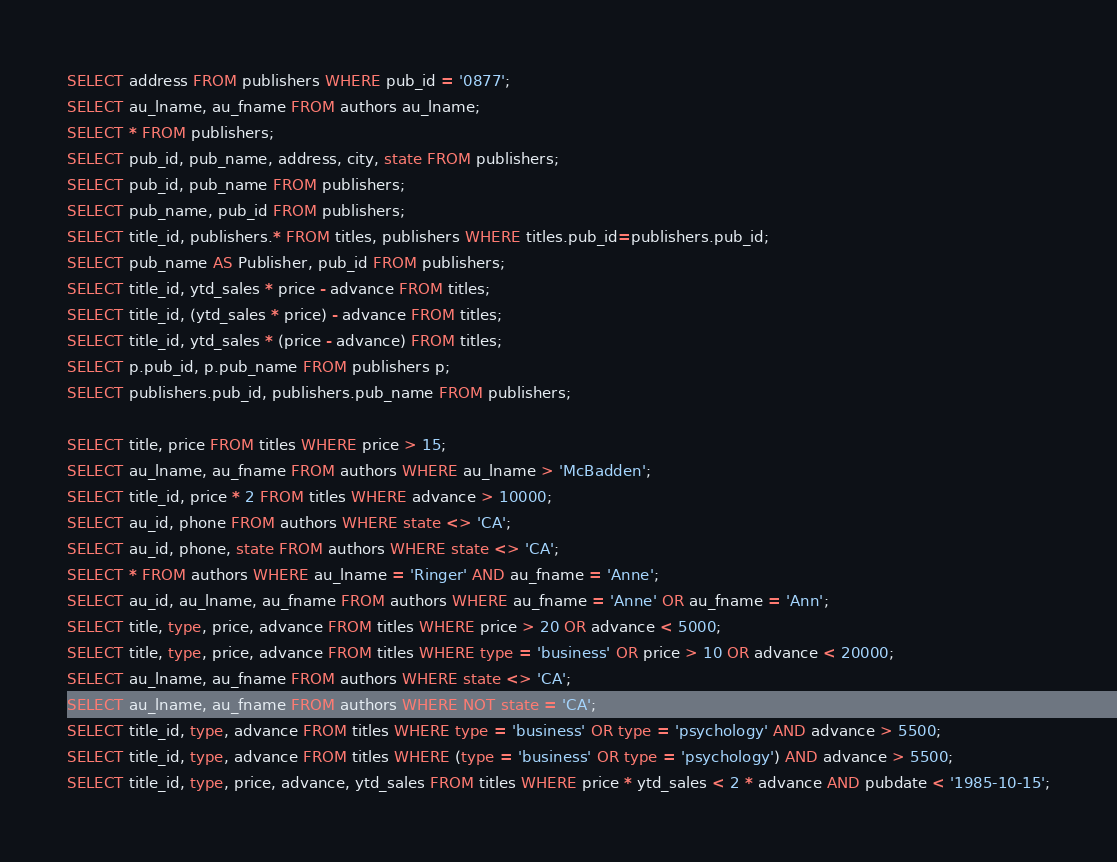<code> <loc_0><loc_0><loc_500><loc_500><_SQL_>SELECT address FROM publishers WHERE pub_id = '0877';
SELECT au_lname, au_fname FROM authors au_lname;
SELECT * FROM publishers;
SELECT pub_id, pub_name, address, city, state FROM publishers;
SELECT pub_id, pub_name FROM publishers;
SELECT pub_name, pub_id FROM publishers;
SELECT title_id, publishers.* FROM titles, publishers WHERE titles.pub_id=publishers.pub_id;
SELECT pub_name AS Publisher, pub_id FROM publishers;
SELECT title_id, ytd_sales * price - advance FROM titles;
SELECT title_id, (ytd_sales * price) - advance FROM titles;
SELECT title_id, ytd_sales * (price - advance) FROM titles;
SELECT p.pub_id, p.pub_name FROM publishers p;
SELECT publishers.pub_id, publishers.pub_name FROM publishers;

SELECT title, price FROM titles WHERE price > 15;
SELECT au_lname, au_fname FROM authors WHERE au_lname > 'McBadden';
SELECT title_id, price * 2 FROM titles WHERE advance > 10000;
SELECT au_id, phone FROM authors WHERE state <> 'CA';
SELECT au_id, phone, state FROM authors WHERE state <> 'CA';
SELECT * FROM authors WHERE au_lname = 'Ringer' AND au_fname = 'Anne';
SELECT au_id, au_lname, au_fname FROM authors WHERE au_fname = 'Anne' OR au_fname = 'Ann';
SELECT title, type, price, advance FROM titles WHERE price > 20 OR advance < 5000;
SELECT title, type, price, advance FROM titles WHERE type = 'business' OR price > 10 OR advance < 20000;
SELECT au_lname, au_fname FROM authors WHERE state <> 'CA';
SELECT au_lname, au_fname FROM authors WHERE NOT state = 'CA';
SELECT title_id, type, advance FROM titles WHERE type = 'business' OR type = 'psychology' AND advance > 5500;
SELECT title_id, type, advance FROM titles WHERE (type = 'business' OR type = 'psychology') AND advance > 5500;
SELECT title_id, type, price, advance, ytd_sales FROM titles WHERE price * ytd_sales < 2 * advance AND pubdate < '1985-10-15';</code> 